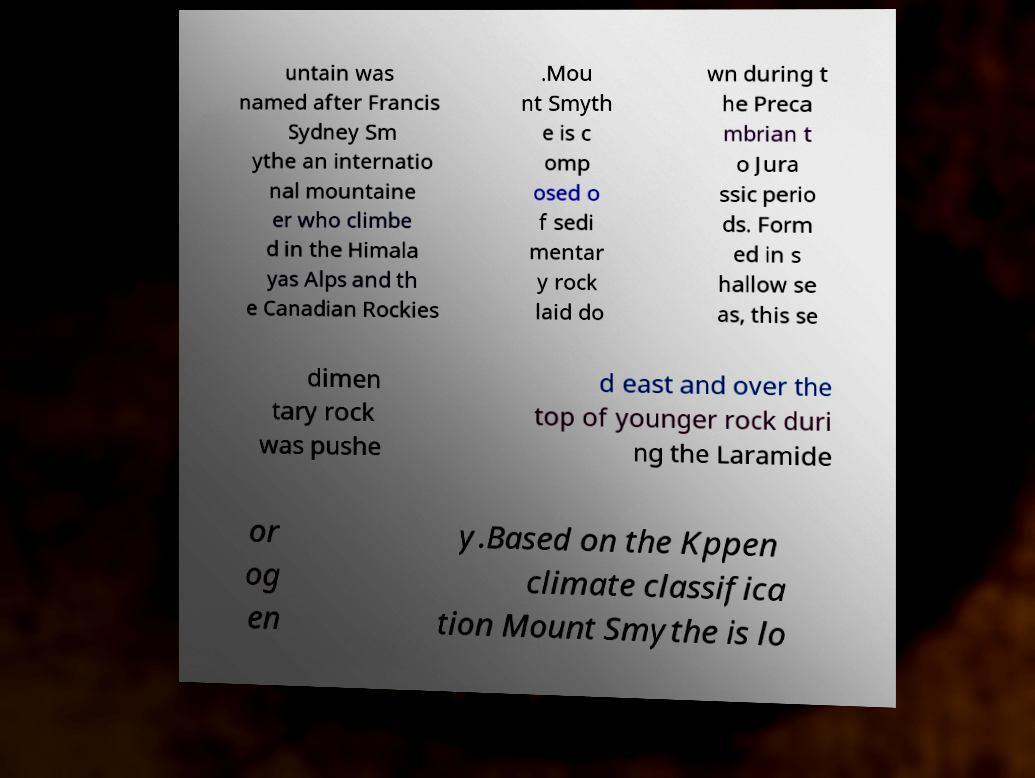Could you extract and type out the text from this image? untain was named after Francis Sydney Sm ythe an internatio nal mountaine er who climbe d in the Himala yas Alps and th e Canadian Rockies .Mou nt Smyth e is c omp osed o f sedi mentar y rock laid do wn during t he Preca mbrian t o Jura ssic perio ds. Form ed in s hallow se as, this se dimen tary rock was pushe d east and over the top of younger rock duri ng the Laramide or og en y.Based on the Kppen climate classifica tion Mount Smythe is lo 